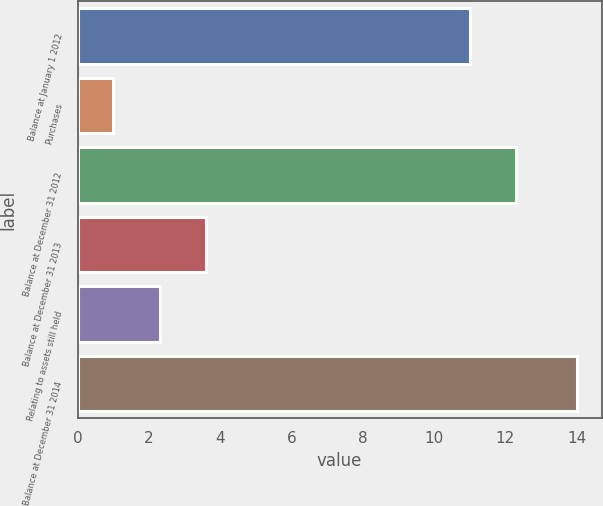Convert chart. <chart><loc_0><loc_0><loc_500><loc_500><bar_chart><fcel>Balance at January 1 2012<fcel>Purchases<fcel>Balance at December 31 2012<fcel>Balance at December 31 2013<fcel>Relating to assets still held<fcel>Balance at December 31 2014<nl><fcel>11<fcel>1<fcel>12.3<fcel>3.6<fcel>2.3<fcel>14<nl></chart> 